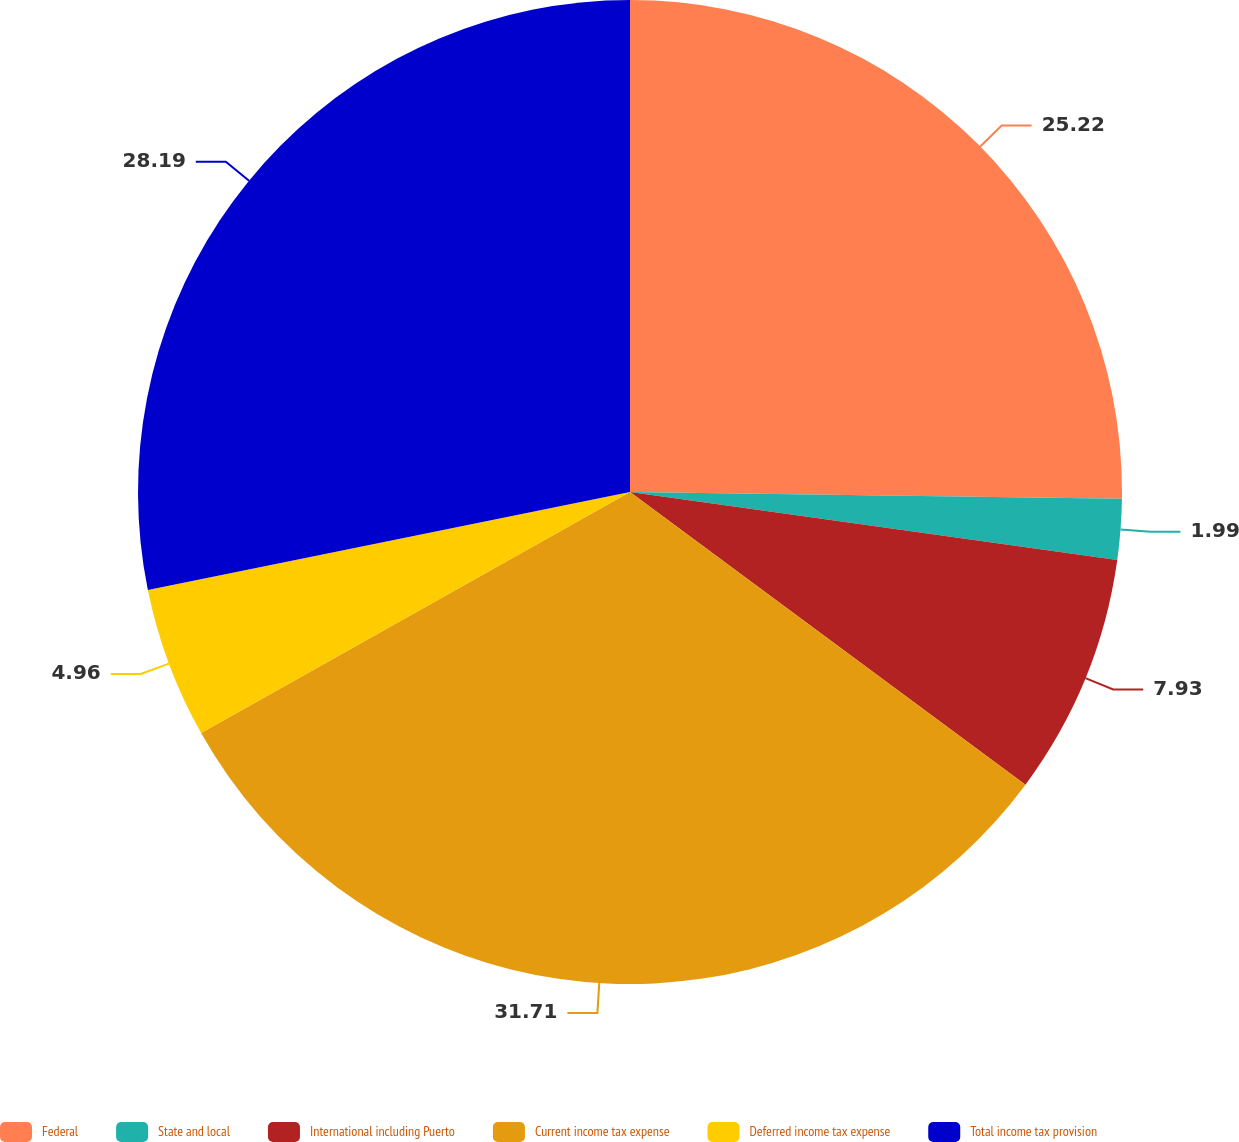Convert chart. <chart><loc_0><loc_0><loc_500><loc_500><pie_chart><fcel>Federal<fcel>State and local<fcel>International including Puerto<fcel>Current income tax expense<fcel>Deferred income tax expense<fcel>Total income tax provision<nl><fcel>25.22%<fcel>1.99%<fcel>7.93%<fcel>31.71%<fcel>4.96%<fcel>28.19%<nl></chart> 